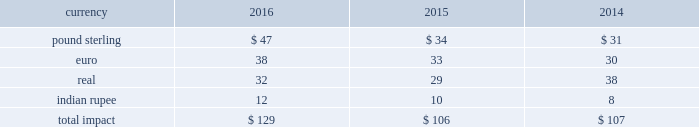Changes in the benchmark index component of the 10-year treasury yield .
The company def signated these derivatives as cash flow hedges .
On october 13 , 2015 , in conjunction with the pricing of the $ 4.5 billion senior notes , the companyr terminated these treasury lock contracts for a cash settlement payment of $ 16 million , which was recorded as a component of other comprehensive earnings and will be reclassified as an adjustment to interest expense over the ten years during which the related interest payments that were hedged will be recognized in income .
Foreign currency risk we are exposed to foreign currency risks that arise from normal business operations .
These risks include the translation of local currency balances of foreign subsidiaries , transaction gains and losses associated with intercompany loans with foreign subsidiaries and transactions denominated in currencies other than a location's functional currency .
We manage the exposure to these risks through a combination of normal operating activities and the use of foreign currency forward contracts .
Contracts are denominated in currtt encies of major industrial countries .
Our exposure to foreign currency exchange risks generally arises from our non-u.s .
Operations , to the extent they are conducted ind local currency .
Changes in foreign currency exchange rates affect translations of revenues denominated in currencies other than the u.s .
Dollar .
During the years ended december 31 , 2016 , 2015 and 2014 , we generated approximately $ 1909 million , $ 1336 million and $ 1229 million , respectively , in revenues denominated in currencies other than the u.s .
Dollar .
The major currencies to which our revenues are exposed are the brazilian real , the euro , the british pound sterling and the indian rupee .
A 10% ( 10 % ) move in average exchange rates for these currencies ( assuming a simultaneous and immediate 10% ( 10 % ) change in all of such rates for the relevant period ) would have resulted in the following increase or ( decrease ) in our reported revenues for the years ended december 31 , 2016 , 2015 and 2014 ( in millions ) : .
While our results of operations have been impacted by the effects of currency fluctuations , our international operations' revenues and expenses are generally denominated in local currency , which reduces our economic exposure to foreign exchange risk in those jurisdictions .
Revenues included $ 100 million and $ 243 million and net earnings included $ 10 million , anrr d $ 31 million , respectively , of unfavorable foreign currency impact during 2016 and 2015 resulting from a stronger u.s .
Dollar during these years compared to thet preceding year .
In 2017 , we expect continued unfavorable foreign currency impact on our operating income resulting from the continued strengthening of the u.s .
Dollar vs .
Other currencies .
Our foreign exchange risk management policy permits the use of derivative instruments , such as forward contracts and options , to reduce volatility in our results of operations and/or cash flows resulting from foreign exchange rate fluctuations .
We do not enter into foreign currency derivative instruments for trading purposes or to engage in speculative activitr y .
We do periodically enter inttt o foreign currency forward exchange contracts to hedge foreign currency exposure to intercompany loans .
As of december 31 , 2016 , the notional amount of these derivatives was approximately $ 143 million and the fair value was nominal .
These derivatives are intended to hedge the foreign exchange risks related to intercompany loans but have not been designated as hedges for accounting purposes .
We also use currency forward contracts to manage our exposure to fluctuations in costs caused by variations in indian rupee ( "inr" ) exchange rates .
As of december 31 , 2016 , the notional amount of these derivatives was approximately $ 7 million and the fair value was ll less than $ 1 million .
These inr forward contracts are designated as cash flow hedges .
The fair value of these currency forward contracts is determined using currency exchange market rates , obtained from reliable , independent , third m party banks , at the balance sheet date .
The fair value of forward contracts is subject to changes in currency exchange rates .
The company has no ineffectiveness related to its use of currency forward contracts in connection with inr cash flow hedges .
In conjunction with entering into the definitive agreement to acquire clear2pay in september 2014 , we initiated a foreign currency forward contract to purchase euros and sell u.s .
Dollars to manage the risk arising from fluctuations in exchange rates until the closing because the purchase price was stated in euros .
As this derivative did not qualify for hedge accounting , we recorded a charge of $ 16 million in other income ( expense ) , net during the third quarter of 2014 .
This forward contract was settled on october 1 , 2014. .
What is the unfavorable foreign currency impact in operating expenses in 2016? 
Computations: (100 - 10)
Answer: 90.0. 